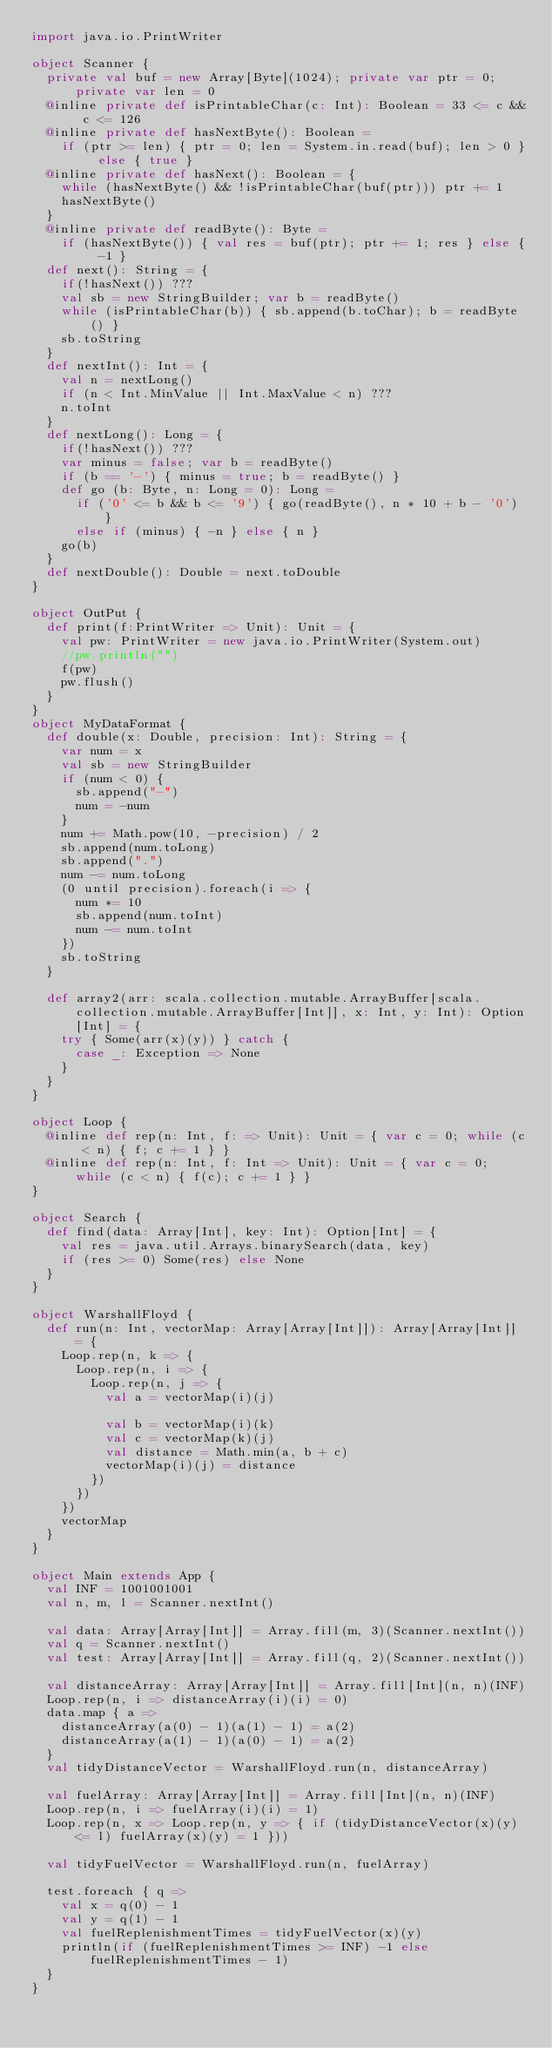<code> <loc_0><loc_0><loc_500><loc_500><_Scala_>import java.io.PrintWriter

object Scanner {
  private val buf = new Array[Byte](1024); private var ptr = 0; private var len = 0
  @inline private def isPrintableChar(c: Int): Boolean = 33 <= c && c <= 126
  @inline private def hasNextByte(): Boolean =
    if (ptr >= len) { ptr = 0; len = System.in.read(buf); len > 0 } else { true }
  @inline private def hasNext(): Boolean = {
    while (hasNextByte() && !isPrintableChar(buf(ptr))) ptr += 1
    hasNextByte()
  }
  @inline private def readByte(): Byte =
    if (hasNextByte()) { val res = buf(ptr); ptr += 1; res } else { -1 }
  def next(): String = {
    if(!hasNext()) ???
    val sb = new StringBuilder; var b = readByte()
    while (isPrintableChar(b)) { sb.append(b.toChar); b = readByte() }
    sb.toString
  }
  def nextInt(): Int = {
    val n = nextLong()
    if (n < Int.MinValue || Int.MaxValue < n) ???
    n.toInt
  }
  def nextLong(): Long = {
    if(!hasNext()) ???
    var minus = false; var b = readByte()
    if (b == '-') { minus = true; b = readByte() }
    def go (b: Byte, n: Long = 0): Long =
      if ('0' <= b && b <= '9') { go(readByte(), n * 10 + b - '0') }
      else if (minus) { -n } else { n }
    go(b)
  }
  def nextDouble(): Double = next.toDouble
}

object OutPut {
  def print(f:PrintWriter => Unit): Unit = {
    val pw: PrintWriter = new java.io.PrintWriter(System.out)
    //pw.println("")
    f(pw)
    pw.flush()
  }
}
object MyDataFormat {
  def double(x: Double, precision: Int): String = {
    var num = x
    val sb = new StringBuilder
    if (num < 0) {
      sb.append("-")
      num = -num
    }
    num += Math.pow(10, -precision) / 2
    sb.append(num.toLong)
    sb.append(".")
    num -= num.toLong
    (0 until precision).foreach(i => {
      num *= 10
      sb.append(num.toInt)
      num -= num.toInt
    })
    sb.toString
  }

  def array2(arr: scala.collection.mutable.ArrayBuffer[scala.collection.mutable.ArrayBuffer[Int]], x: Int, y: Int): Option[Int] = {
    try { Some(arr(x)(y)) } catch {
      case _: Exception => None
    }
  }
}

object Loop {
  @inline def rep(n: Int, f: => Unit): Unit = { var c = 0; while (c < n) { f; c += 1 } }
  @inline def rep(n: Int, f: Int => Unit): Unit = { var c = 0; while (c < n) { f(c); c += 1 } }
}

object Search {
  def find(data: Array[Int], key: Int): Option[Int] = {
    val res = java.util.Arrays.binarySearch(data, key)
    if (res >= 0) Some(res) else None
  }
}

object WarshallFloyd {
  def run(n: Int, vectorMap: Array[Array[Int]]): Array[Array[Int]] = {
    Loop.rep(n, k => {
      Loop.rep(n, i => {
        Loop.rep(n, j => {
          val a = vectorMap(i)(j)

          val b = vectorMap(i)(k)
          val c = vectorMap(k)(j)
          val distance = Math.min(a, b + c)
          vectorMap(i)(j) = distance
        })
      })
    })
    vectorMap
  }
}

object Main extends App {
  val INF = 1001001001
  val n, m, l = Scanner.nextInt()

  val data: Array[Array[Int]] = Array.fill(m, 3)(Scanner.nextInt())
  val q = Scanner.nextInt()
  val test: Array[Array[Int]] = Array.fill(q, 2)(Scanner.nextInt())

  val distanceArray: Array[Array[Int]] = Array.fill[Int](n, n)(INF)
  Loop.rep(n, i => distanceArray(i)(i) = 0)
  data.map { a =>
    distanceArray(a(0) - 1)(a(1) - 1) = a(2)
    distanceArray(a(1) - 1)(a(0) - 1) = a(2)
  }
  val tidyDistanceVector = WarshallFloyd.run(n, distanceArray)

  val fuelArray: Array[Array[Int]] = Array.fill[Int](n, n)(INF)
  Loop.rep(n, i => fuelArray(i)(i) = 1)
  Loop.rep(n, x => Loop.rep(n, y => { if (tidyDistanceVector(x)(y) <= l) fuelArray(x)(y) = 1 }))

  val tidyFuelVector = WarshallFloyd.run(n, fuelArray)

  test.foreach { q =>
    val x = q(0) - 1
    val y = q(1) - 1
    val fuelReplenishmentTimes = tidyFuelVector(x)(y)
    println(if (fuelReplenishmentTimes >= INF) -1 else fuelReplenishmentTimes - 1)
  }
}</code> 